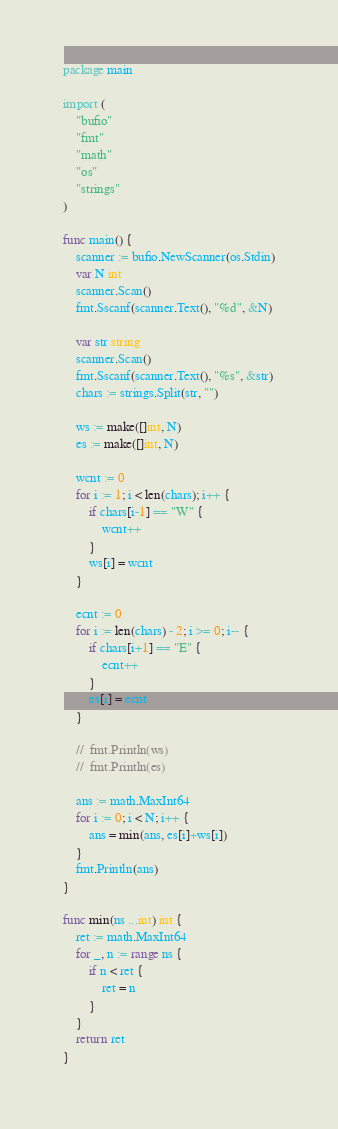Convert code to text. <code><loc_0><loc_0><loc_500><loc_500><_Go_>package main

import (
	"bufio"
	"fmt"
	"math"
	"os"
	"strings"
)

func main() {
	scanner := bufio.NewScanner(os.Stdin)
	var N int
	scanner.Scan()
	fmt.Sscanf(scanner.Text(), "%d", &N)

	var str string
	scanner.Scan()
	fmt.Sscanf(scanner.Text(), "%s", &str)
	chars := strings.Split(str, "")

	ws := make([]int, N)
	es := make([]int, N)

	wcnt := 0
	for i := 1; i < len(chars); i++ {
		if chars[i-1] == "W" {
			wcnt++
		}
		ws[i] = wcnt
	}

	ecnt := 0
	for i := len(chars) - 2; i >= 0; i-- {
		if chars[i+1] == "E" {
			ecnt++
		}
		es[i] = ecnt
	}

	//	fmt.Println(ws)
	//  fmt.Println(es)

	ans := math.MaxInt64
	for i := 0; i < N; i++ {
		ans = min(ans, es[i]+ws[i])
	}
	fmt.Println(ans)
}

func min(ns ...int) int {
	ret := math.MaxInt64
	for _, n := range ns {
		if n < ret {
			ret = n
		}
	}
	return ret
}
</code> 